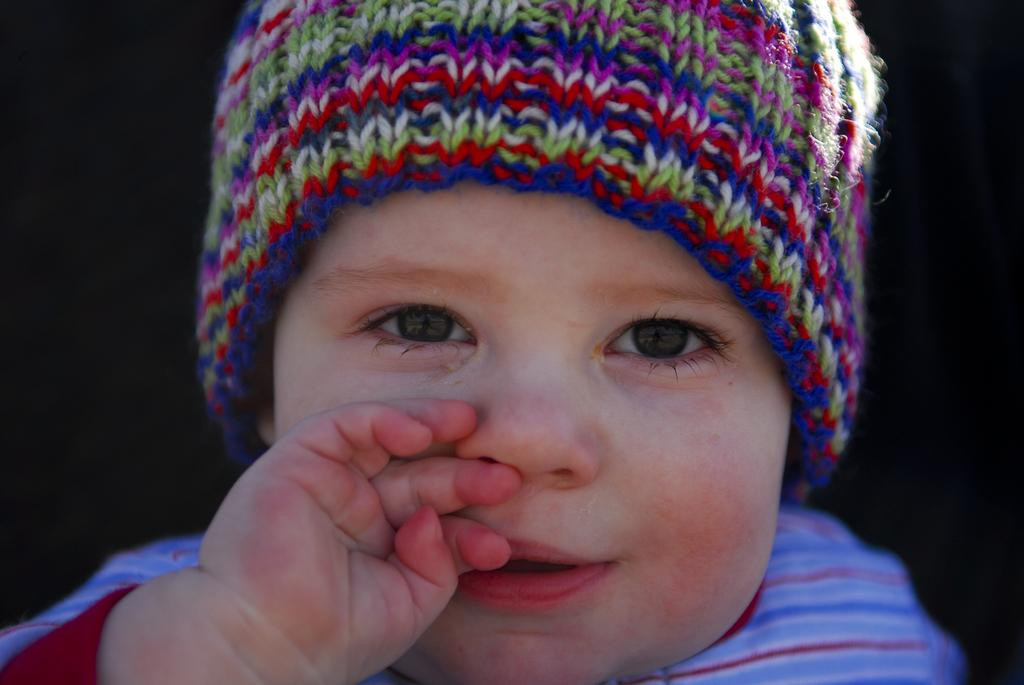What is the main subject of the picture? The main subject of the picture is a baby. What is the baby wearing on their head? The baby is wearing a headgear. What color is the shirt the baby is wearing? The baby is wearing a red color shirt. What is the baby's facial expression in the picture? The baby is smiling. How would you describe the background of the image? The backdrop of the image is dark. Can you see the van's tail in the image? There is no van or tail present in the image; it features a baby with a headgear and a red shirt. 